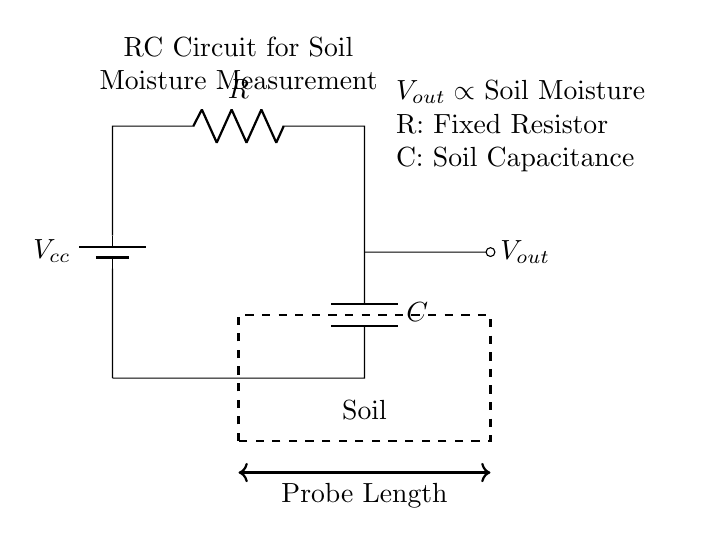What is the voltage source in this circuit? The voltage source is labeled as Vcc, which indicates the positive voltage supply for the circuit.
Answer: Vcc What does Vout represent in this circuit? Vout is the output voltage, which depends on the resistance of the soil and its moisture content, reflecting the soil's capacitance.
Answer: Output voltage What component measures soil moisture levels in this design? The soil capacitance, represented by the capacitor C, is the primary component responsible for the measurement of soil moisture based on its capacitance.
Answer: Capacitor How are the resistor and capacitor connected in this circuit? The resistor R is connected in series with the capacitor C; they are connected in a loop with the voltage supply to form the RC circuit.
Answer: Series What happens to Vout when soil moisture increases? When soil moisture increases, it causes the resistance of the soil to decrease, resulting in an increase in Vout.
Answer: Increases What is the relationship between resistance and soil moisture in this circuit? The relationship is inverse; as soil moisture increases, the resistance decreases, which in turn increases the output voltage Vout.
Answer: Inverse relationship What factors affect the output voltage in this RC circuit? The output voltage is affected by the soil moisture level (capacitance changes due to moisture) and the fixed resistor value.
Answer: Soil moisture and resistor value 